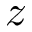<formula> <loc_0><loc_0><loc_500><loc_500>z</formula> 